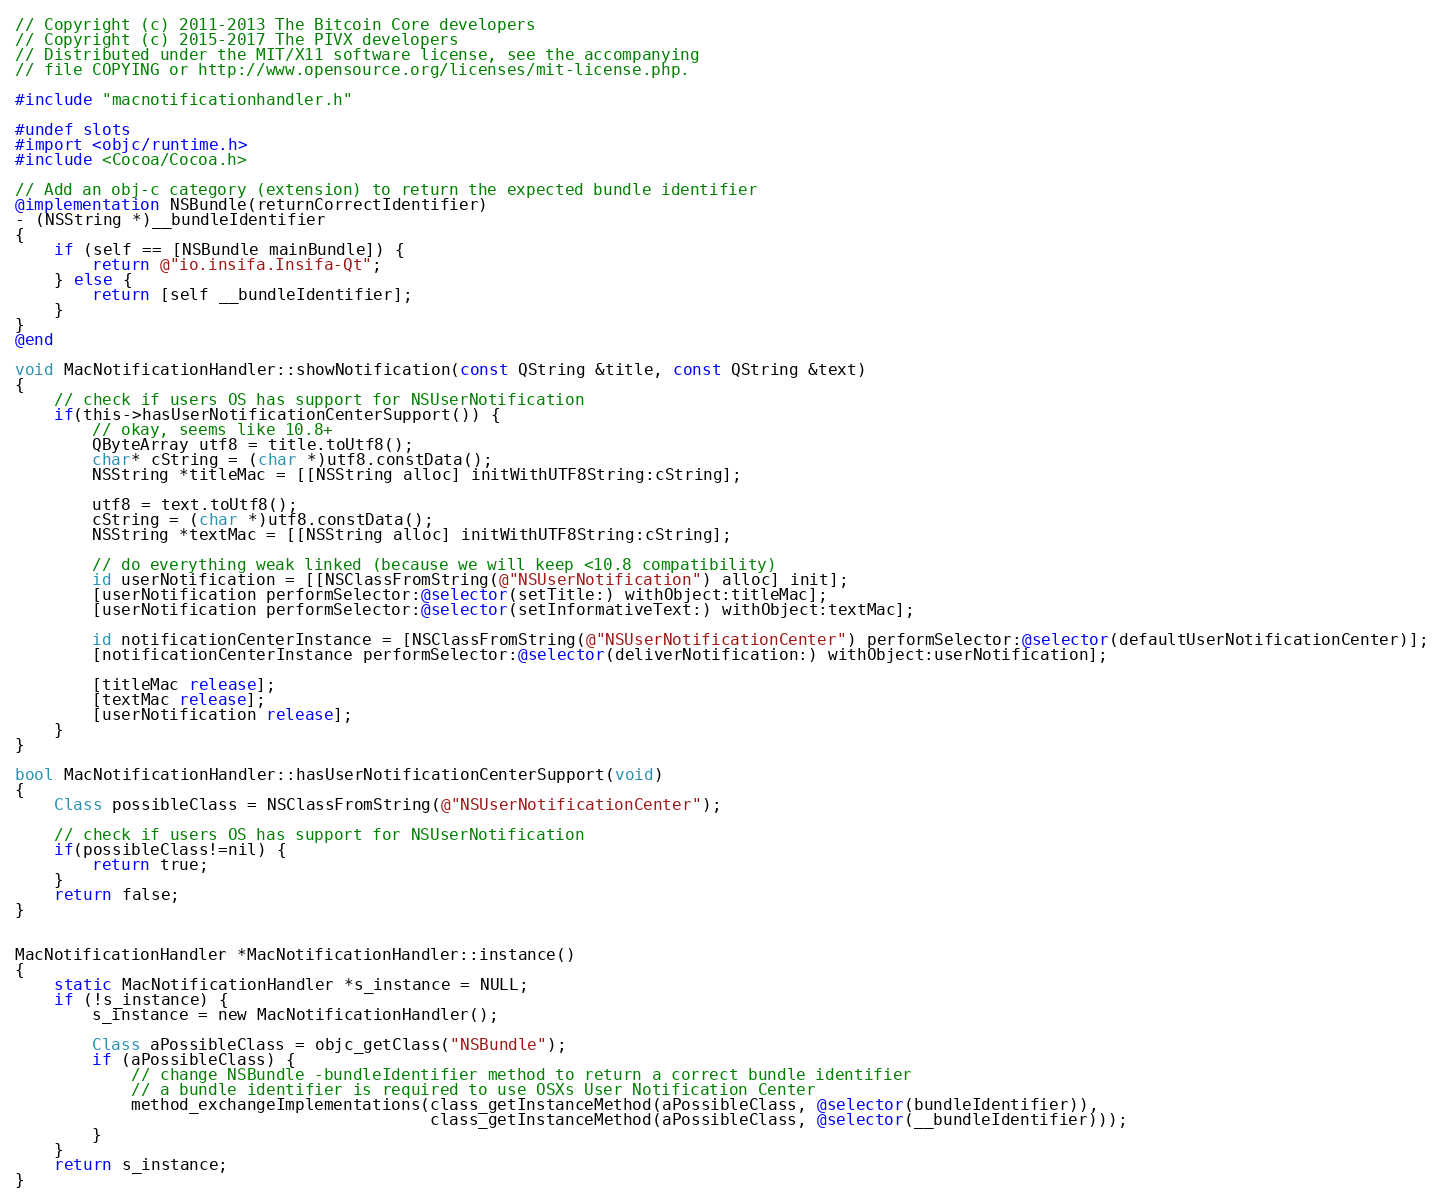Convert code to text. <code><loc_0><loc_0><loc_500><loc_500><_ObjectiveC_>// Copyright (c) 2011-2013 The Bitcoin Core developers
// Copyright (c) 2015-2017 The PIVX developers
// Distributed under the MIT/X11 software license, see the accompanying
// file COPYING or http://www.opensource.org/licenses/mit-license.php.

#include "macnotificationhandler.h"

#undef slots
#import <objc/runtime.h>
#include <Cocoa/Cocoa.h>

// Add an obj-c category (extension) to return the expected bundle identifier
@implementation NSBundle(returnCorrectIdentifier)
- (NSString *)__bundleIdentifier
{
    if (self == [NSBundle mainBundle]) {
        return @"io.insifa.Insifa-Qt";
    } else {
        return [self __bundleIdentifier];
    }
}
@end

void MacNotificationHandler::showNotification(const QString &title, const QString &text)
{
    // check if users OS has support for NSUserNotification
    if(this->hasUserNotificationCenterSupport()) {
        // okay, seems like 10.8+
        QByteArray utf8 = title.toUtf8();
        char* cString = (char *)utf8.constData();
        NSString *titleMac = [[NSString alloc] initWithUTF8String:cString];

        utf8 = text.toUtf8();
        cString = (char *)utf8.constData();
        NSString *textMac = [[NSString alloc] initWithUTF8String:cString];

        // do everything weak linked (because we will keep <10.8 compatibility)
        id userNotification = [[NSClassFromString(@"NSUserNotification") alloc] init];
        [userNotification performSelector:@selector(setTitle:) withObject:titleMac];
        [userNotification performSelector:@selector(setInformativeText:) withObject:textMac];

        id notificationCenterInstance = [NSClassFromString(@"NSUserNotificationCenter") performSelector:@selector(defaultUserNotificationCenter)];
        [notificationCenterInstance performSelector:@selector(deliverNotification:) withObject:userNotification];

        [titleMac release];
        [textMac release];
        [userNotification release];
    }
}

bool MacNotificationHandler::hasUserNotificationCenterSupport(void)
{
    Class possibleClass = NSClassFromString(@"NSUserNotificationCenter");

    // check if users OS has support for NSUserNotification
    if(possibleClass!=nil) {
        return true;
    }
    return false;
}


MacNotificationHandler *MacNotificationHandler::instance()
{
    static MacNotificationHandler *s_instance = NULL;
    if (!s_instance) {
        s_instance = new MacNotificationHandler();

        Class aPossibleClass = objc_getClass("NSBundle");
        if (aPossibleClass) {
            // change NSBundle -bundleIdentifier method to return a correct bundle identifier
            // a bundle identifier is required to use OSXs User Notification Center
            method_exchangeImplementations(class_getInstanceMethod(aPossibleClass, @selector(bundleIdentifier)),
                                           class_getInstanceMethod(aPossibleClass, @selector(__bundleIdentifier)));
        }
    }
    return s_instance;
}
</code> 